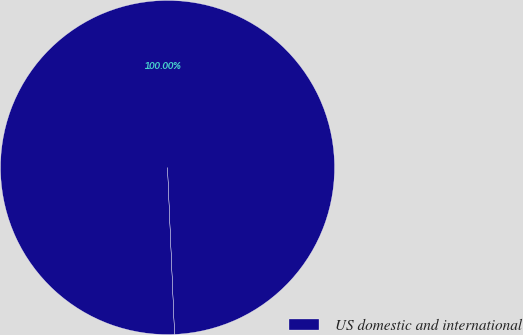Convert chart. <chart><loc_0><loc_0><loc_500><loc_500><pie_chart><fcel>US domestic and international<nl><fcel>100.0%<nl></chart> 